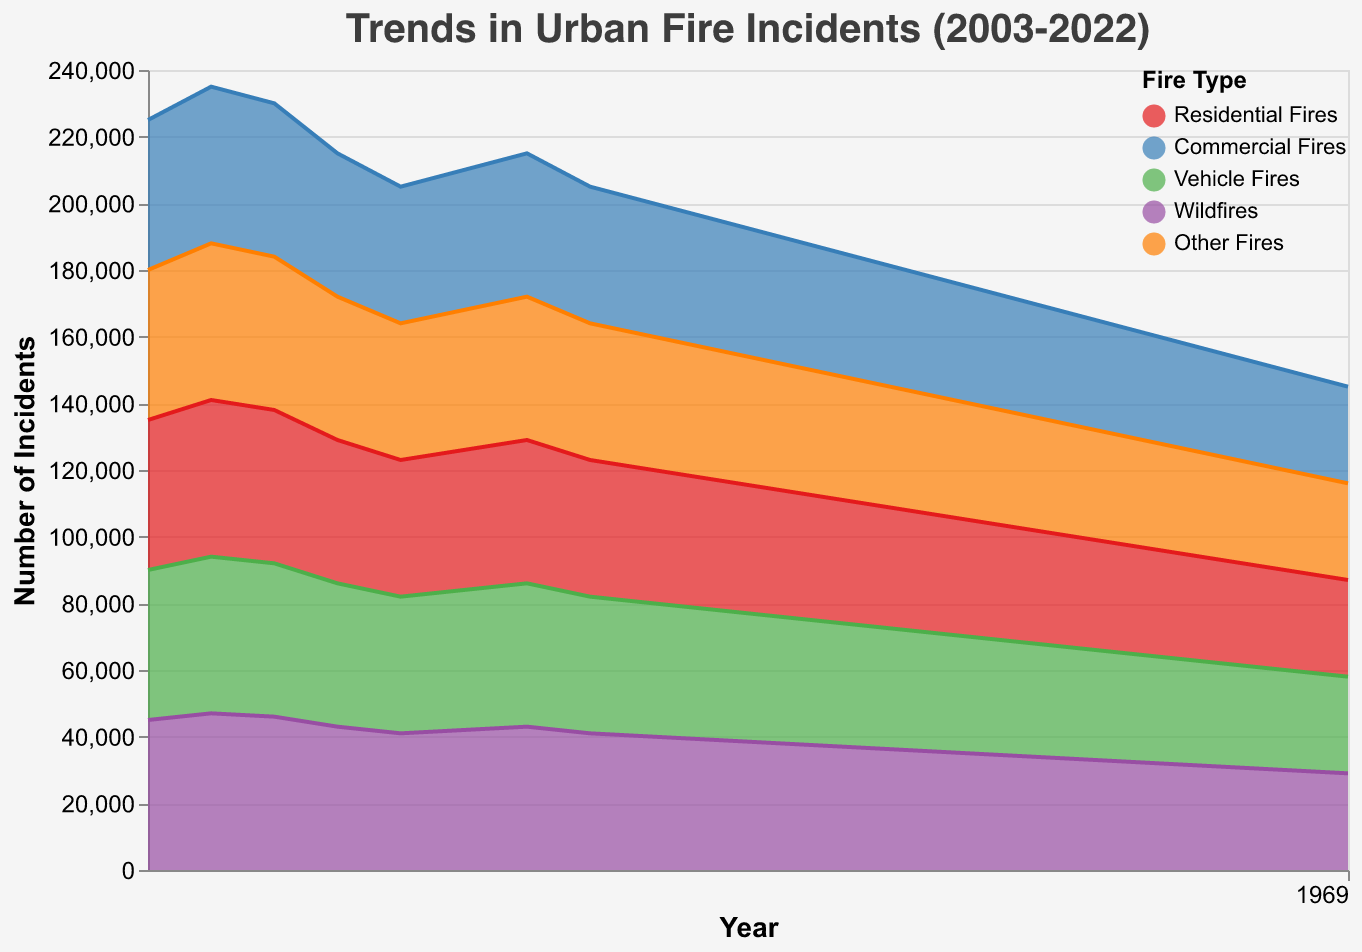How many types of fires are tracked in the trend data? The legend shows five distinct fire types: Residential Fires, Commercial Fires, Vehicle Fires, Wildfires, and Other Fires.
Answer: 5 Which type of fire has the highest number of incidents in 2003? By looking at the area chart for the year 2003, the largest area section corresponds to Residential Fires.
Answer: Residential Fires How do the incidents of Vehicle Fires in 2022 compare to those in 2010? For Vehicle Fires, compare the heights of the area sections for the years 2022 and 2010. The chart shows higher incidents in 2010 than in 2022.
Answer: Higher in 2010 Calculate the average number of Wildfires from 2003 to 2022. Add the Wildfire incidents for each year from 2003 to 2022, then divide by the number of years (20). (5000+4800+4900+4600+4400+4300+4200+4100+4000+4100+3900+3800+3700+3600+3400+3200+3000+2900+2800+2700)/20 = 3745
Answer: 3745 What's the trend of Residential Fires from 2003 to 2022? Observing the area corresponding to Residential Fires, it shows a consistent decline from 45000 incidents in 2003 to 29000 incidents in 2022.
Answer: Decreasing trend Which year had the highest number of Commercial Fires? By looking at the peaks in the area corresponding to Commercial Fires, 2022 shows the highest number.
Answer: 2022 Compare the sum of incidents for Wildfires and Other Fires in 2022. Add the total number of Wildfires (2700) and Other Fires (2100) incidents for 2022: 2700 + 2100 = 4800.
Answer: 4800 In which year did Residential Fires drop below 40,000 incidents for the first time? Observing the area chart, the area for Residential Fires drops below the 40000 mark first in the year 2012.
Answer: 2012 What was the total number of incidents for all fire types in the year 2010? Sum the incidents for each fire type in 2010: 41000 (Residential) + 12800 (Commercial) + 7000 (Vehicle) + 4100 (Wildfires) + 3400 (Other) = 68300.
Answer: 68300 